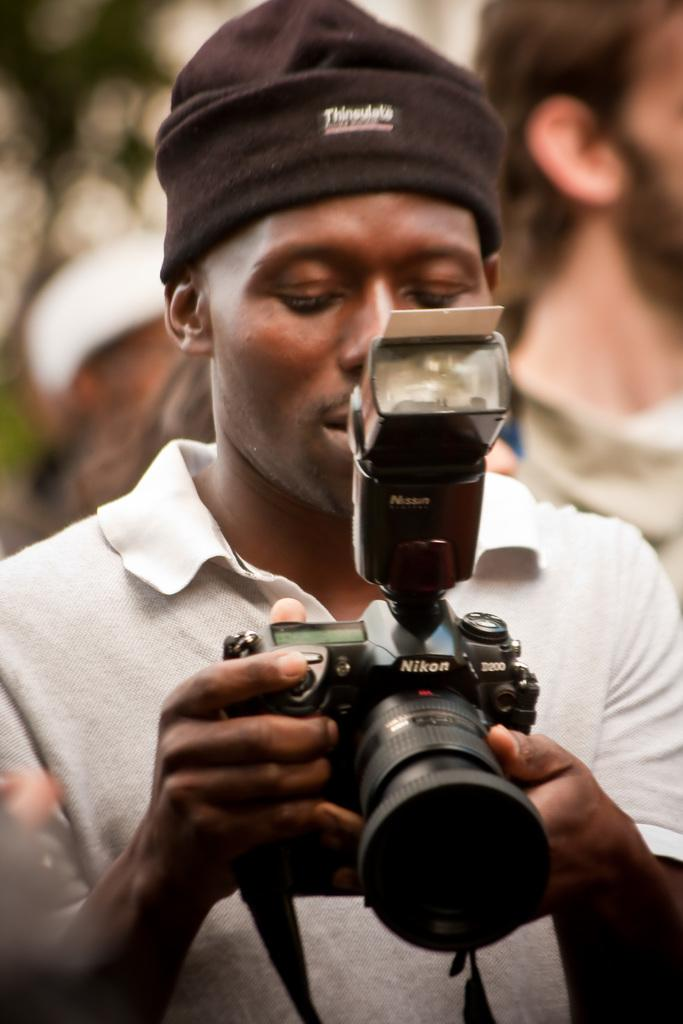Who is present in the image? There is a man in the image. What is the man wearing on his upper body? The man is wearing a white t-shirt. What is the man holding in his hands? The man is holding a camera in his hands. What type of headwear is the man wearing? The man is wearing a cap on his head. How many beds are visible in the image? There are no beds visible in the image; it features a man holding a camera. What type of cloud is present in the image? There is no cloud present in the image; it is focused on a man holding a camera. 